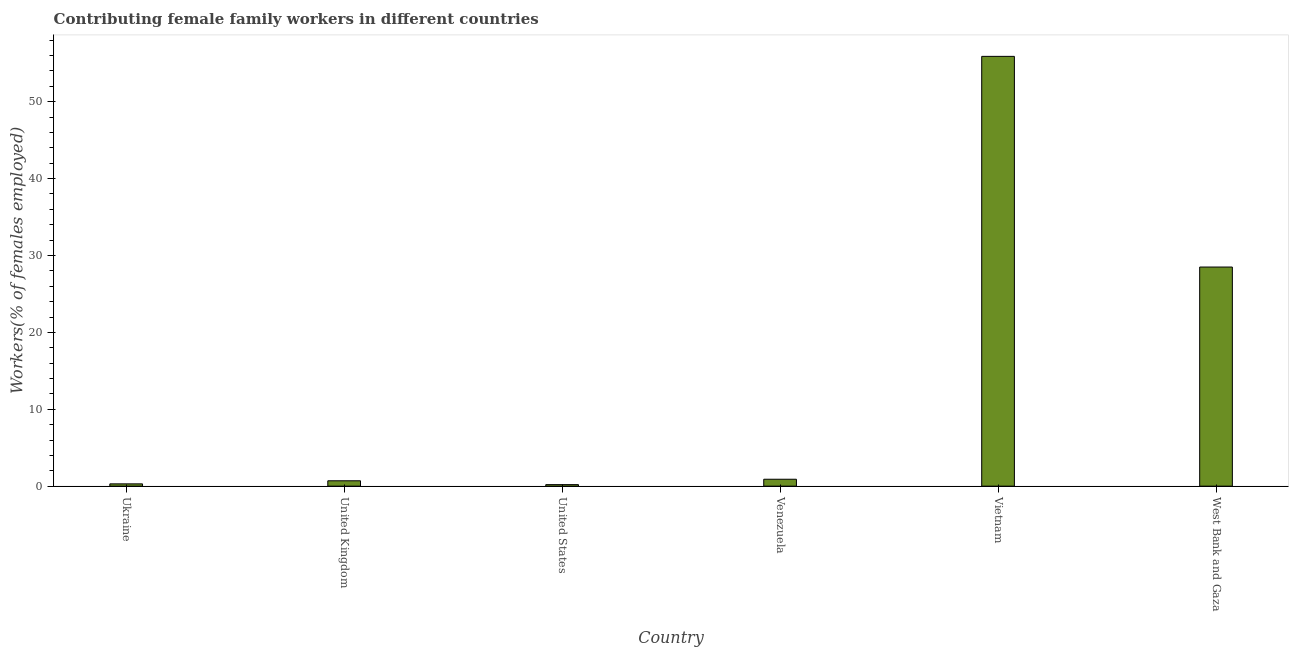Does the graph contain any zero values?
Provide a succinct answer. No. Does the graph contain grids?
Ensure brevity in your answer.  No. What is the title of the graph?
Provide a succinct answer. Contributing female family workers in different countries. What is the label or title of the X-axis?
Keep it short and to the point. Country. What is the label or title of the Y-axis?
Ensure brevity in your answer.  Workers(% of females employed). What is the contributing female family workers in United Kingdom?
Your answer should be compact. 0.7. Across all countries, what is the maximum contributing female family workers?
Your response must be concise. 55.9. Across all countries, what is the minimum contributing female family workers?
Your answer should be compact. 0.2. In which country was the contributing female family workers maximum?
Offer a very short reply. Vietnam. What is the sum of the contributing female family workers?
Keep it short and to the point. 86.5. What is the difference between the contributing female family workers in Ukraine and United States?
Your answer should be very brief. 0.1. What is the average contributing female family workers per country?
Make the answer very short. 14.42. What is the median contributing female family workers?
Make the answer very short. 0.8. In how many countries, is the contributing female family workers greater than 16 %?
Your response must be concise. 2. What is the ratio of the contributing female family workers in Venezuela to that in West Bank and Gaza?
Offer a very short reply. 0.03. Is the difference between the contributing female family workers in Ukraine and Venezuela greater than the difference between any two countries?
Keep it short and to the point. No. What is the difference between the highest and the second highest contributing female family workers?
Offer a terse response. 27.4. Is the sum of the contributing female family workers in United Kingdom and United States greater than the maximum contributing female family workers across all countries?
Your response must be concise. No. What is the difference between the highest and the lowest contributing female family workers?
Your answer should be compact. 55.7. How many bars are there?
Your answer should be compact. 6. Are the values on the major ticks of Y-axis written in scientific E-notation?
Offer a very short reply. No. What is the Workers(% of females employed) of Ukraine?
Make the answer very short. 0.3. What is the Workers(% of females employed) in United Kingdom?
Make the answer very short. 0.7. What is the Workers(% of females employed) of United States?
Provide a succinct answer. 0.2. What is the Workers(% of females employed) of Venezuela?
Offer a very short reply. 0.9. What is the Workers(% of females employed) of Vietnam?
Make the answer very short. 55.9. What is the difference between the Workers(% of females employed) in Ukraine and United Kingdom?
Give a very brief answer. -0.4. What is the difference between the Workers(% of females employed) in Ukraine and Vietnam?
Ensure brevity in your answer.  -55.6. What is the difference between the Workers(% of females employed) in Ukraine and West Bank and Gaza?
Provide a succinct answer. -28.2. What is the difference between the Workers(% of females employed) in United Kingdom and Vietnam?
Offer a very short reply. -55.2. What is the difference between the Workers(% of females employed) in United Kingdom and West Bank and Gaza?
Offer a terse response. -27.8. What is the difference between the Workers(% of females employed) in United States and Venezuela?
Offer a very short reply. -0.7. What is the difference between the Workers(% of females employed) in United States and Vietnam?
Offer a very short reply. -55.7. What is the difference between the Workers(% of females employed) in United States and West Bank and Gaza?
Provide a succinct answer. -28.3. What is the difference between the Workers(% of females employed) in Venezuela and Vietnam?
Provide a succinct answer. -55. What is the difference between the Workers(% of females employed) in Venezuela and West Bank and Gaza?
Keep it short and to the point. -27.6. What is the difference between the Workers(% of females employed) in Vietnam and West Bank and Gaza?
Your answer should be very brief. 27.4. What is the ratio of the Workers(% of females employed) in Ukraine to that in United Kingdom?
Make the answer very short. 0.43. What is the ratio of the Workers(% of females employed) in Ukraine to that in Venezuela?
Your response must be concise. 0.33. What is the ratio of the Workers(% of females employed) in Ukraine to that in Vietnam?
Your answer should be compact. 0.01. What is the ratio of the Workers(% of females employed) in Ukraine to that in West Bank and Gaza?
Keep it short and to the point. 0.01. What is the ratio of the Workers(% of females employed) in United Kingdom to that in Venezuela?
Offer a very short reply. 0.78. What is the ratio of the Workers(% of females employed) in United Kingdom to that in Vietnam?
Your answer should be compact. 0.01. What is the ratio of the Workers(% of females employed) in United Kingdom to that in West Bank and Gaza?
Offer a very short reply. 0.03. What is the ratio of the Workers(% of females employed) in United States to that in Venezuela?
Offer a terse response. 0.22. What is the ratio of the Workers(% of females employed) in United States to that in Vietnam?
Make the answer very short. 0. What is the ratio of the Workers(% of females employed) in United States to that in West Bank and Gaza?
Your response must be concise. 0.01. What is the ratio of the Workers(% of females employed) in Venezuela to that in Vietnam?
Provide a short and direct response. 0.02. What is the ratio of the Workers(% of females employed) in Venezuela to that in West Bank and Gaza?
Your answer should be very brief. 0.03. What is the ratio of the Workers(% of females employed) in Vietnam to that in West Bank and Gaza?
Provide a succinct answer. 1.96. 